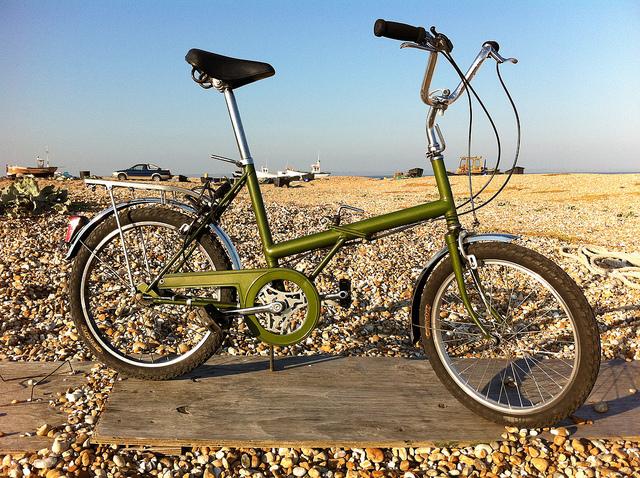What color is the bike?
Short answer required. Green. Is the bike leaning against something?
Write a very short answer. No. Is the bicycle the main subject of the picture?
Concise answer only. Yes. What is the round green metal on the bike for?
Answer briefly. Frame. Where is the bike?
Keep it brief. Beach. Is this a cloudy day?
Quick response, please. No. What color is the seat?
Quick response, please. Black. 